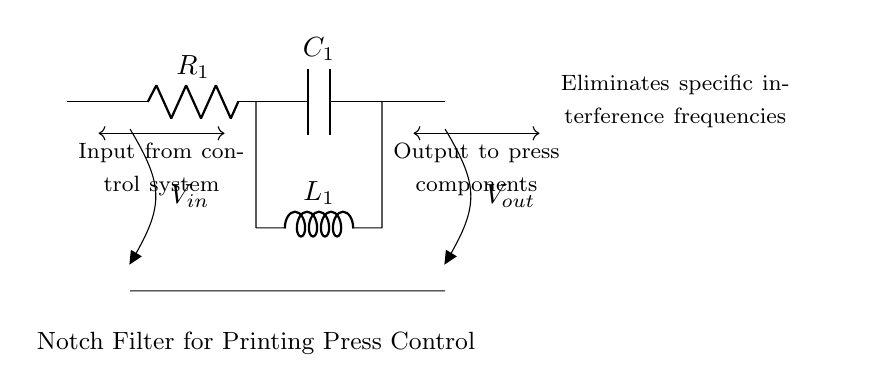What components are present in the circuit? The circuit includes a resistor, a capacitor, and an inductor. Each component is identified by its symbol and labeled accordingly in the diagram.
Answer: Resistor, capacitor, inductor What is the input voltage labeled as in this circuit? The input voltage is labeled as V_in, indicated by the symbol near the left side of the circuit where the input is connected.
Answer: V_in What is the output voltage labeled as in this circuit? The output voltage is labeled as V_out, shown at the right side of the circuit where the output is taken from the circuit.
Answer: V_out How many total components are in this notch filter? The total count of components includes one resistor, one capacitor, and one inductor, adding up to three components in the circuit.
Answer: Three What type of filter is represented in this circuit? The circuit diagram represents a notch filter, which is used to eliminate specific interference frequencies from signals. This is indicated in the title and function description of the circuit.
Answer: Notch filter Why is a notch filter used in printing press control systems? A notch filter is used to reduce or eliminate specific interference frequencies that can cause issues in the control signals, ensuring smoother operation of printing components. This reasoning is derived from the circuit's purpose as stated in the diagram.
Answer: To reduce interference frequencies 